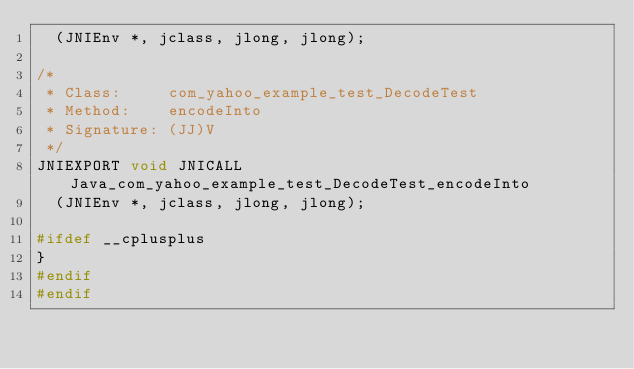<code> <loc_0><loc_0><loc_500><loc_500><_C_>  (JNIEnv *, jclass, jlong, jlong);

/*
 * Class:     com_yahoo_example_test_DecodeTest
 * Method:    encodeInto
 * Signature: (JJ)V
 */
JNIEXPORT void JNICALL Java_com_yahoo_example_test_DecodeTest_encodeInto
  (JNIEnv *, jclass, jlong, jlong);

#ifdef __cplusplus
}
#endif
#endif
</code> 